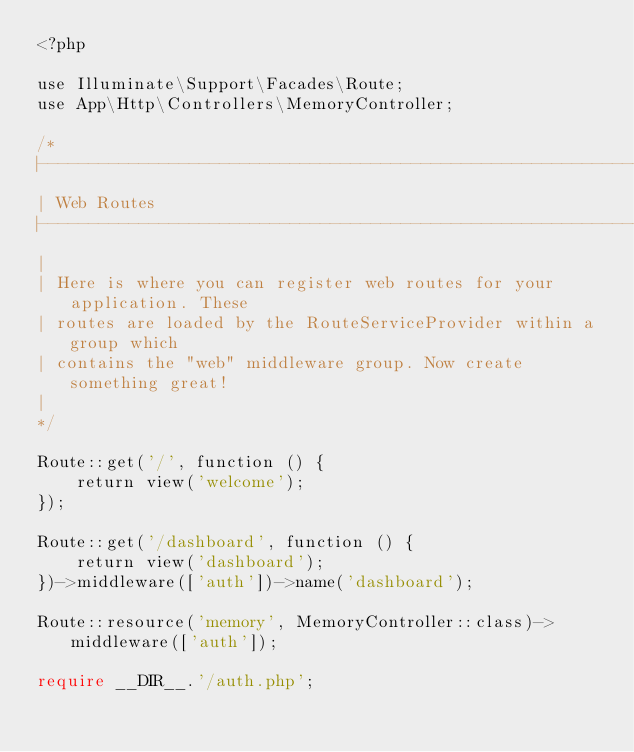Convert code to text. <code><loc_0><loc_0><loc_500><loc_500><_PHP_><?php

use Illuminate\Support\Facades\Route;
use App\Http\Controllers\MemoryController;

/*
|--------------------------------------------------------------------------
| Web Routes
|--------------------------------------------------------------------------
|
| Here is where you can register web routes for your application. These
| routes are loaded by the RouteServiceProvider within a group which
| contains the "web" middleware group. Now create something great!
|
*/

Route::get('/', function () {
    return view('welcome');
});

Route::get('/dashboard', function () {
    return view('dashboard');
})->middleware(['auth'])->name('dashboard');

Route::resource('memory', MemoryController::class)->middleware(['auth']);

require __DIR__.'/auth.php';
</code> 